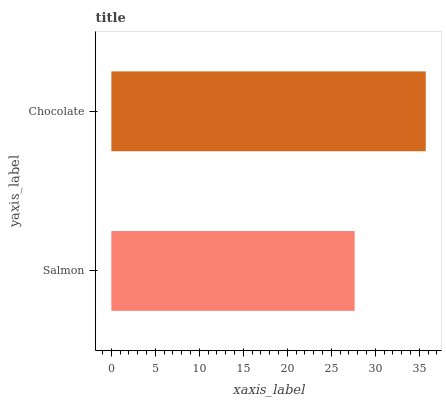Is Salmon the minimum?
Answer yes or no. Yes. Is Chocolate the maximum?
Answer yes or no. Yes. Is Chocolate the minimum?
Answer yes or no. No. Is Chocolate greater than Salmon?
Answer yes or no. Yes. Is Salmon less than Chocolate?
Answer yes or no. Yes. Is Salmon greater than Chocolate?
Answer yes or no. No. Is Chocolate less than Salmon?
Answer yes or no. No. Is Chocolate the high median?
Answer yes or no. Yes. Is Salmon the low median?
Answer yes or no. Yes. Is Salmon the high median?
Answer yes or no. No. Is Chocolate the low median?
Answer yes or no. No. 